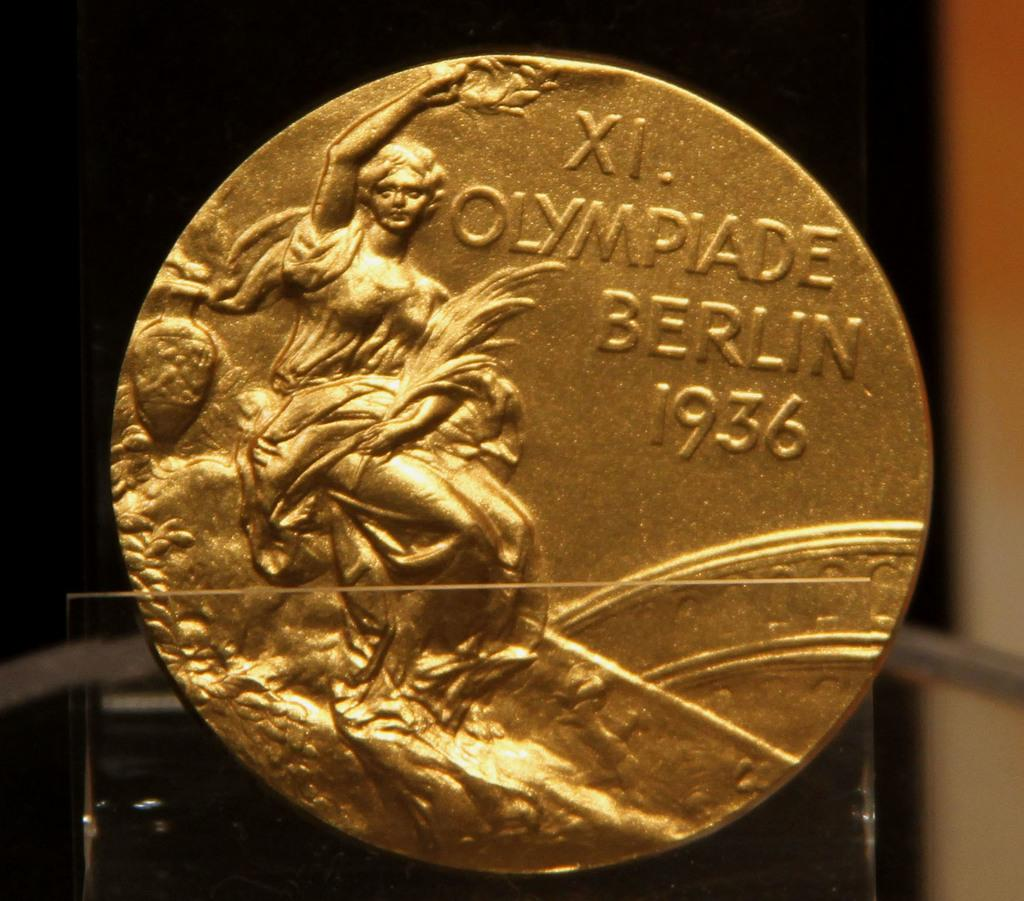<image>
Present a compact description of the photo's key features. A Xi. Olympiade Berlin 1936 Olympic gold medal from the Berlin Olympic Games. 